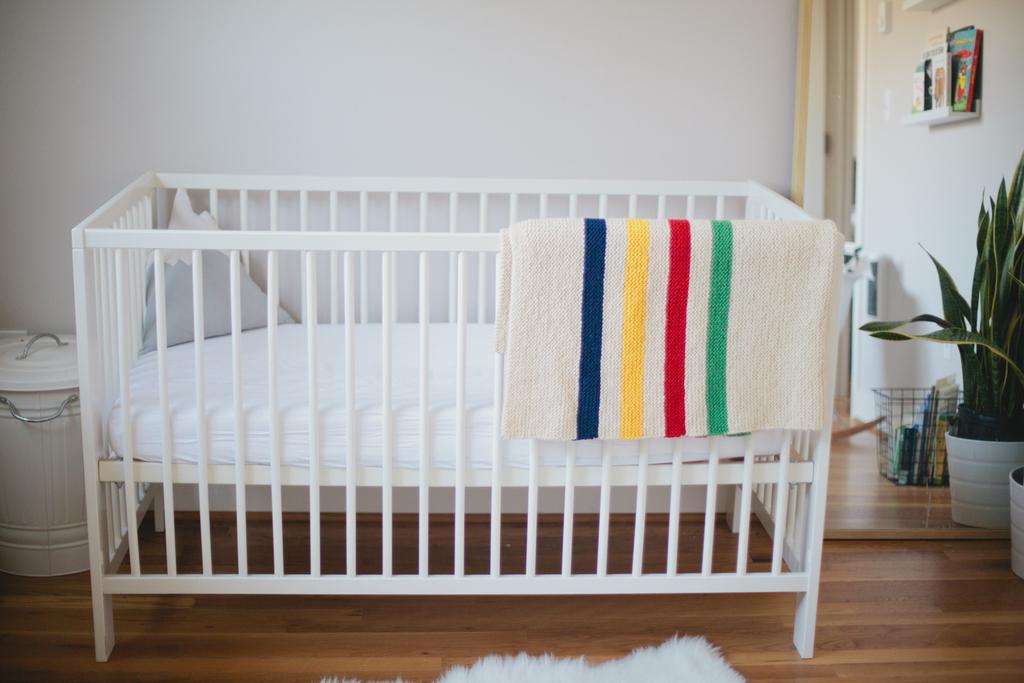How would you summarize this image in a sentence or two? In this picture I can see the floor, on which I can see a crib in front, on which there is a colorful and on the left side of this image I can see a white color can. On the right side of this image I can see the plants and few things on the right top corner. In the background I can see the white wall. 